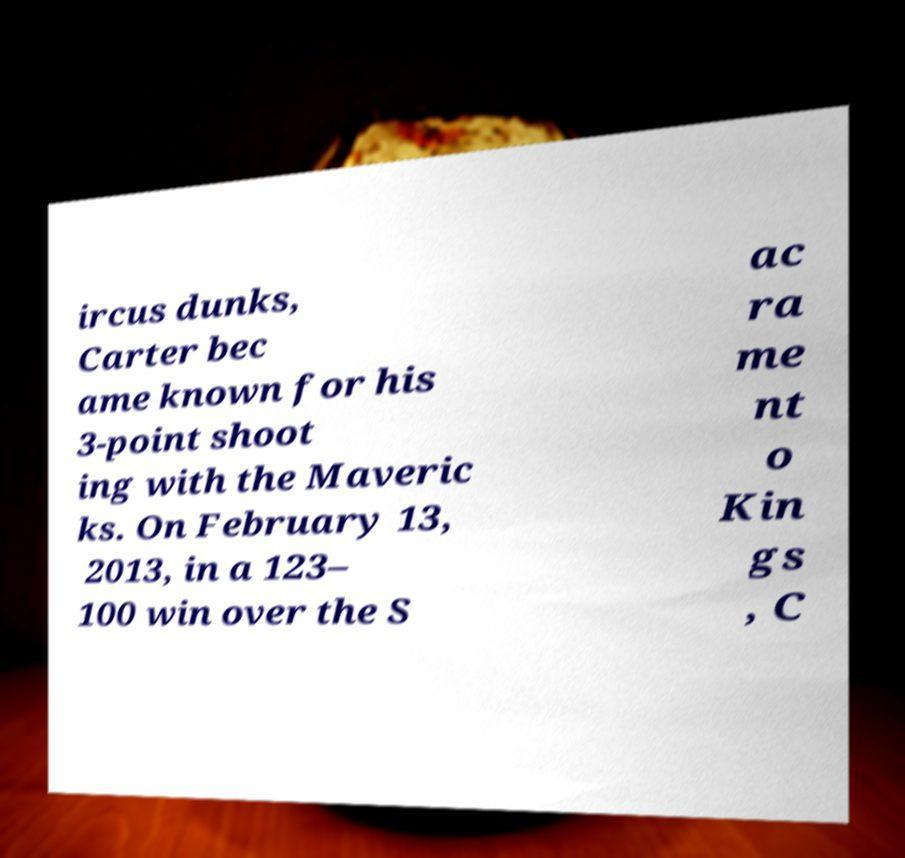What messages or text are displayed in this image? I need them in a readable, typed format. ircus dunks, Carter bec ame known for his 3-point shoot ing with the Maveric ks. On February 13, 2013, in a 123– 100 win over the S ac ra me nt o Kin gs , C 